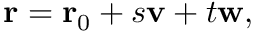<formula> <loc_0><loc_0><loc_500><loc_500>r = r _ { 0 } + s v + t w ,</formula> 